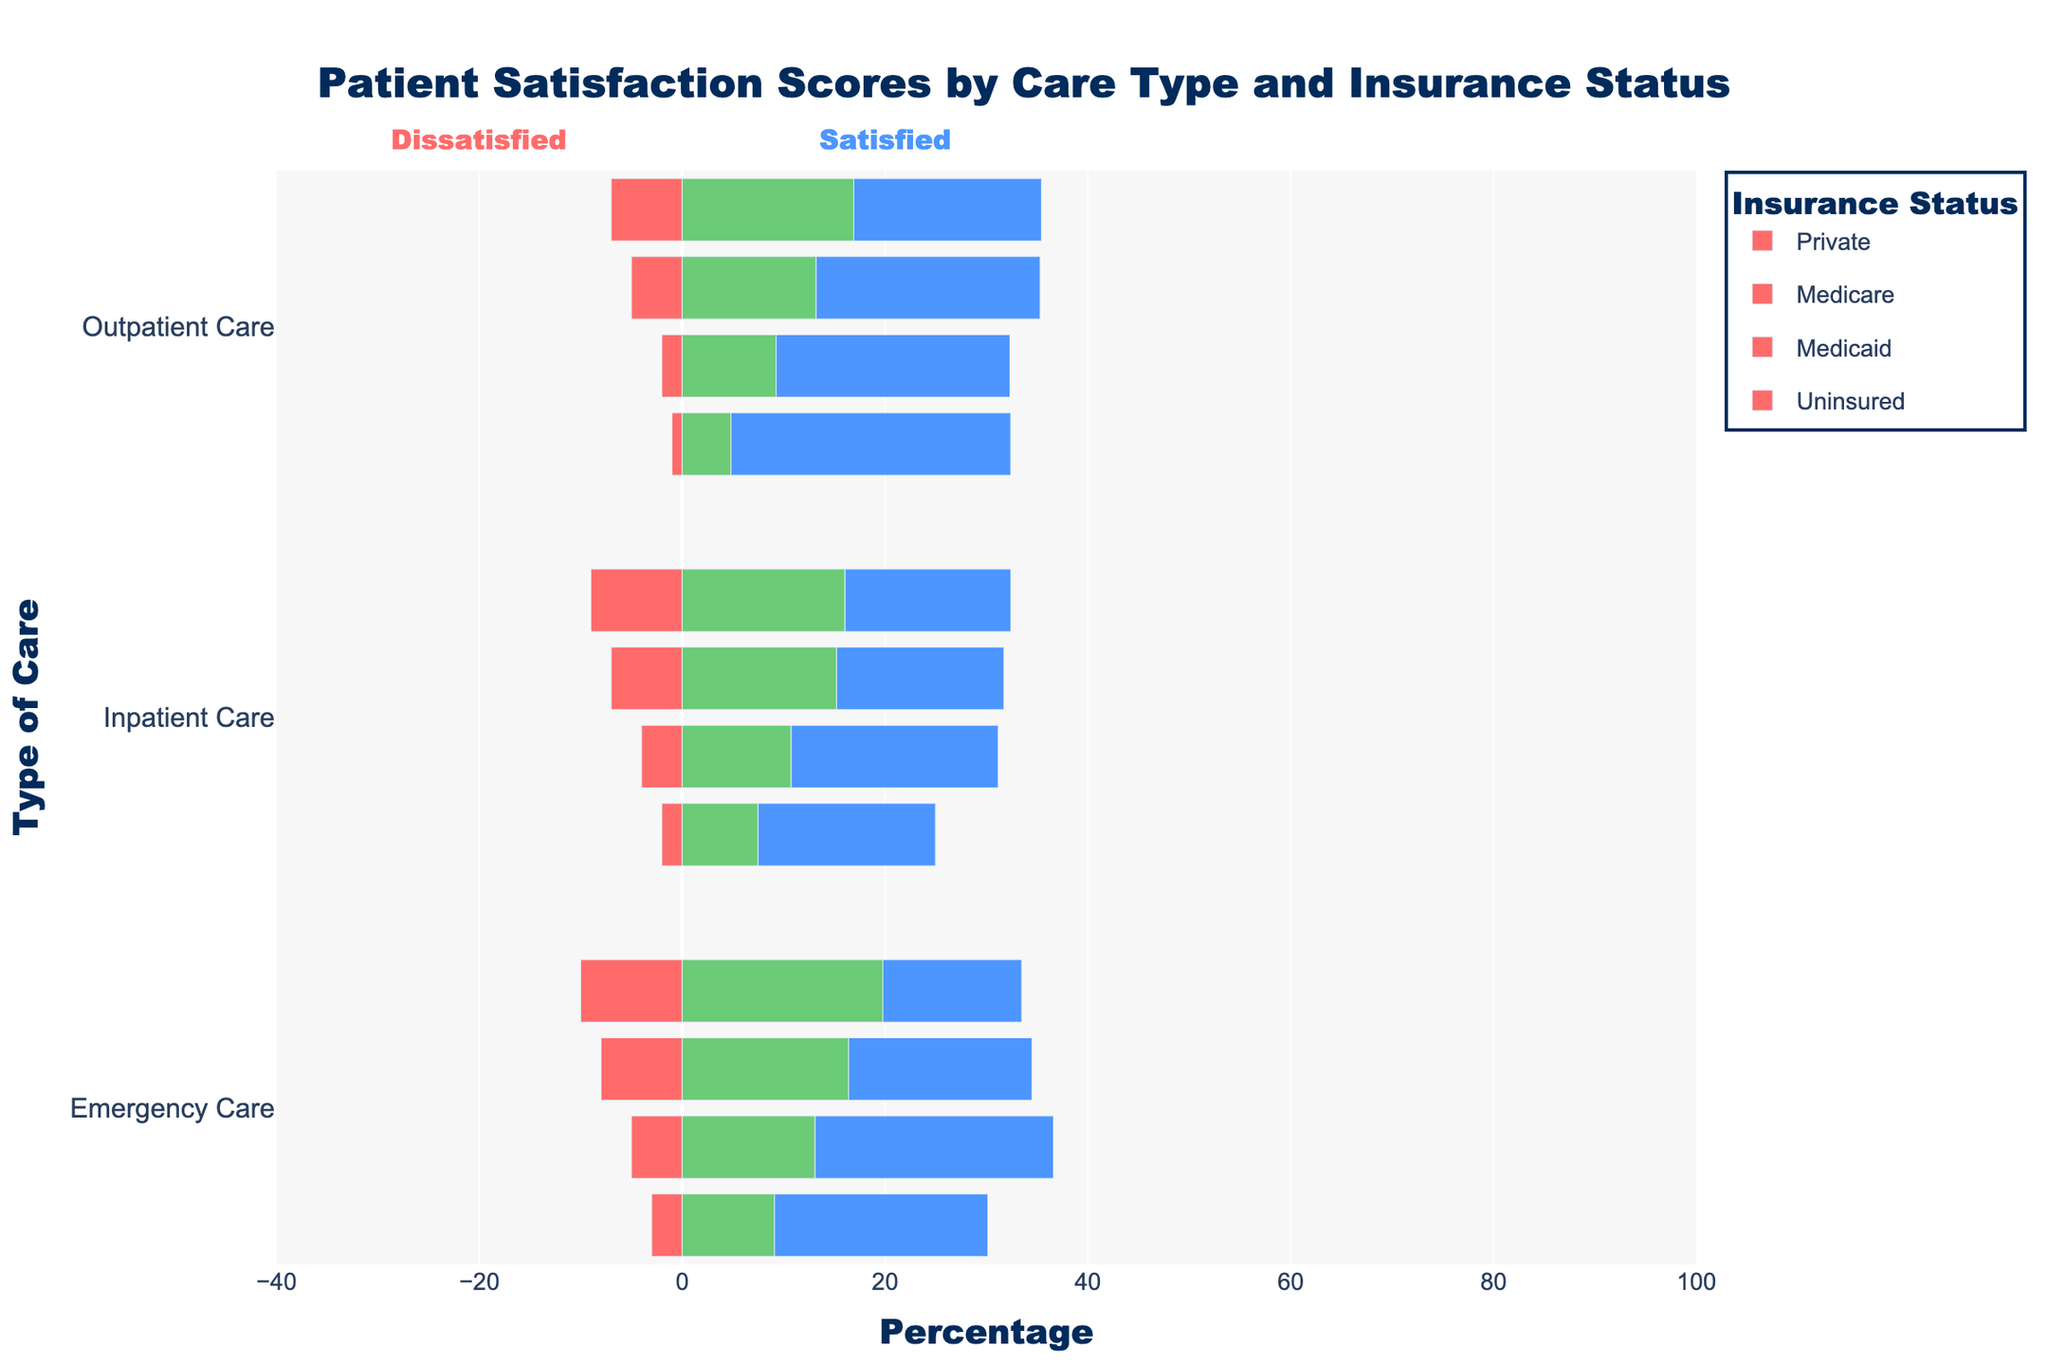What is the percentage of "Very Satisfied" patients in Emergency Care for those with Private Insurance? Locate the bar for Emergency Care under Private Insurance. Check the section corresponding to "Very Satisfied" and refer to the length of the bar in the blue color.
Answer: 55% Compare the satisfaction levels between Medicare and Uninsured for Inpatient Care. Who has a higher percentage of "Satisfied" patients? Look at the bars for Inpatient Care under both Medicare and Uninsured. Identify the "Satisfied" section (light blue). Medicare has a wider bar indicating a higher percentage of "Satisfied" patients.
Answer: Medicare Which type of care and insurance status combination has the highest percentage of "Neutral" patients? Examine each bar for the green "Neutral" section. The longest green bar among all combinations represents the highest percentage.
Answer: Emergency Care, Uninsured What is the combined percentage of "Very Dissatisfied" and "Dissatisfied" patients for Medicaid under Emergency Care? Identify the red and yellow sections for Medicaid under Emergency Care, then sum their percentages. Red section is 8%, yellow section is 15%, so 8% + 15% = 23%.
Answer: 23% Which insurance status under Outpatient Care has the fewest "Very Satisfied" patients? Look at the Outpatient Care bars and find the section corresponding to "Very Satisfied" (dark blue). Compare the lengths and determine the shortest one.
Answer: Uninsured Order the insurance statuses under Emergency Care by "Dissatisfied" percentage, from highest to lowest. Compare the yellow "Dissatisfied" sections across all insurance statuses under Emergency Care. From the lengths: Uninsured (18%), Medicaid (15%), Medicare (10%), Private (7%).
Answer: Uninsured, Medicaid, Medicare, Private How much higher is the "Very Satisfied" percentage for Private insurance in Outpatient Care compared to Medicaid in the same type of care? Find the "Very Satisfied" section for Private insurance in Outpatient Care (61%). Find the same for Medicaid (43%). Calculate the difference (61% - 43% = 18%).
Answer: 18% Which type of care shows the highest overall satisfaction (sum of "Satisfied" and "Very Satisfied") for Medicare? Sum the "Satisfied" and "Very Satisfied" sections for Medicare in each type of care. Compare the total lengths: Emergency Care (30% + 40% = 70%), Inpatient Care (25% + 51% = 76%), Outpatient Care (27% + 55% = 82%).
Answer: Outpatient Care What is the total percentage of satisfied patients (sum of "Satisfied" and "Very Satisfied") in Inpatient Care for all insurance statuses? Calculate the sum of "Satisfied" and "Very Satisfied" for each insurance status in Inpatient Care and then add these values. Private (20% + 65% = 85%), Medicare (25% + 51% = 76%), Medicaid (22% + 41% = 63%), Uninsured (23% + 31% = 54%). Total is 85% + 76% + 63% + 54% = 278%.
Answer: 278% 